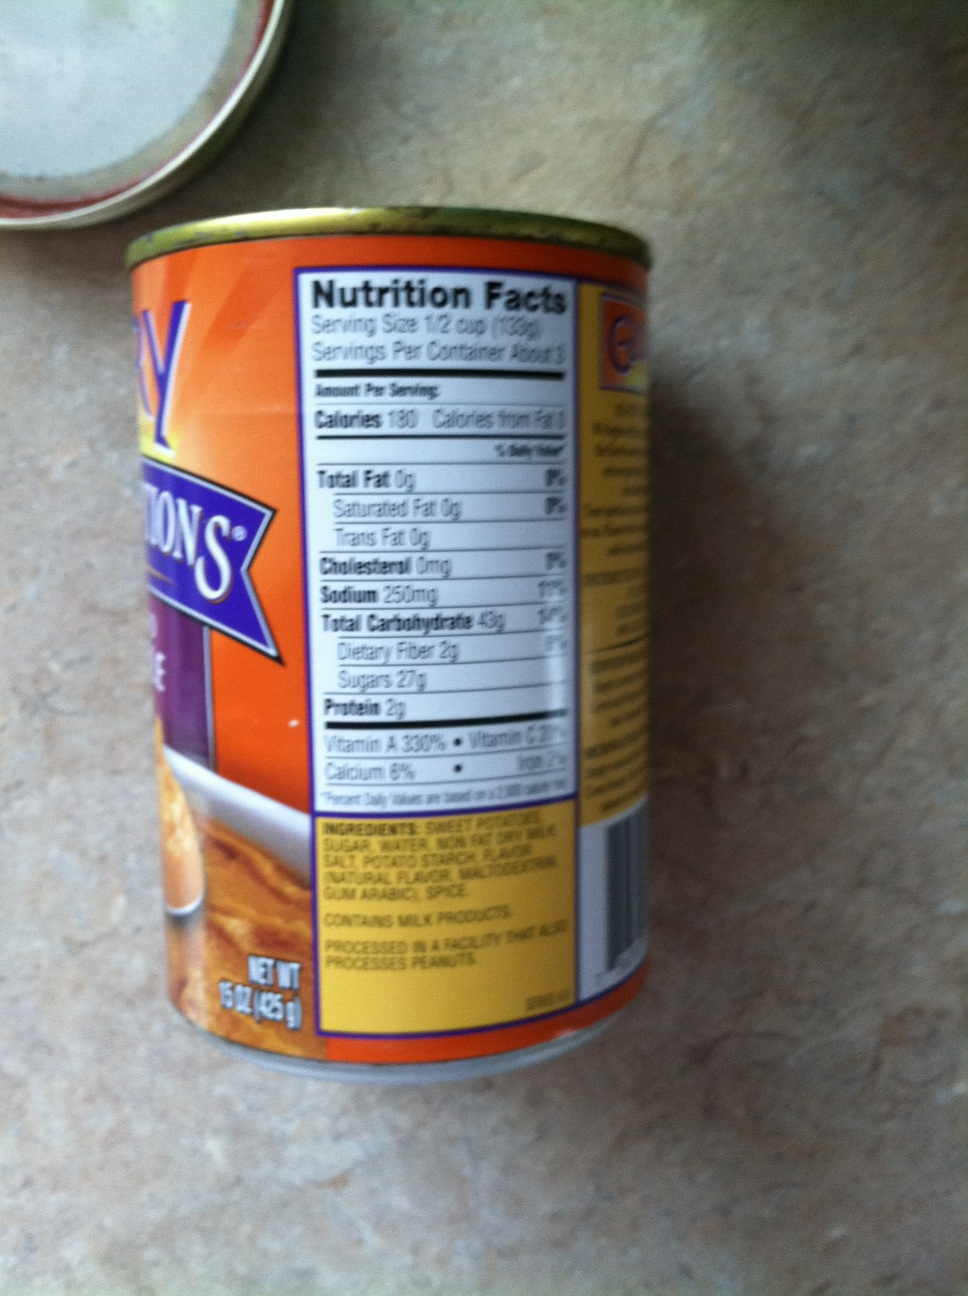Imagining a culinary adventure, what exotic dish could you create with the contents of this tin? With the sweet potatoes from this tin, you could create an exotic Sweet Potato and Coconut Curry. Start by sautéing onions, garlic, and ginger in a pot. Add in the sweet potatoes from the tin, along with some diced tomatoes, coconut milk, and a mix of spices such as curry powder, cumin, and coriander. Let it simmer until the flavors meld together, then serve over a bed of jasmine rice and garnish with fresh cilantro and a squeeze of lime. This dish combines the natural sweetness of the potatoes with the rich, creamy texture of coconut milk, creating a delicious and warming meal. 